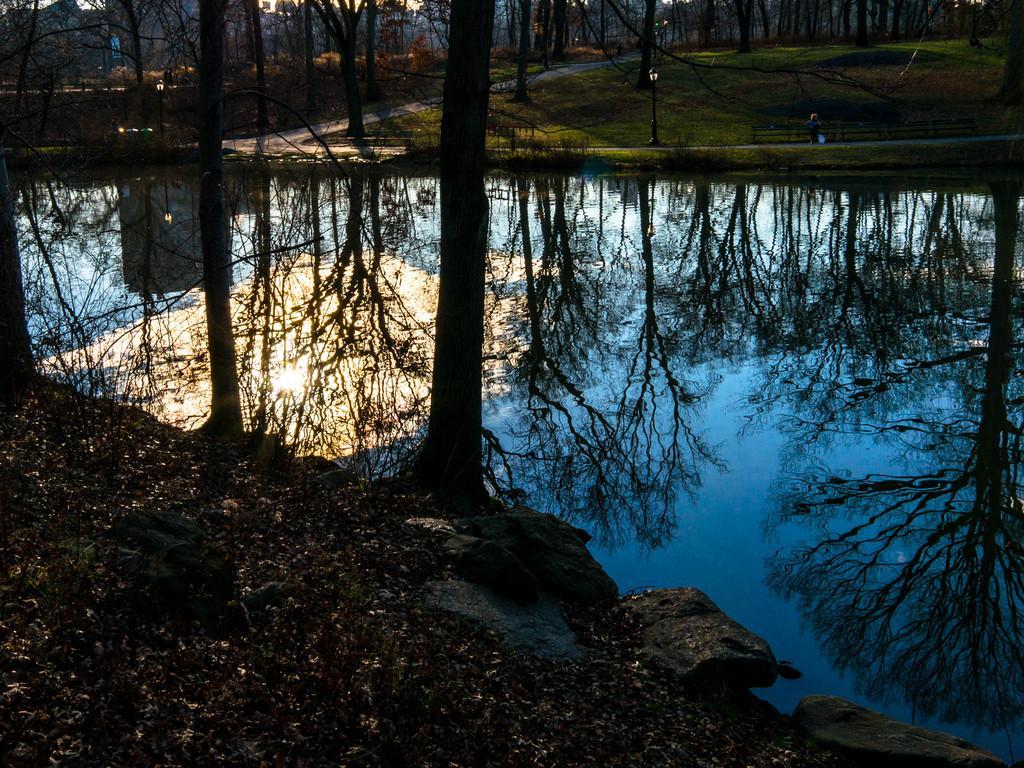In one or two sentences, can you explain what this image depicts? In this image there is water in the middle and there are tall trees on either side of the water. In the water there are reflections of the trees. At the bottom there are dry leaves on the ground and there are stones beside it. In the background there is a path in the middle and there is grass beside it. 